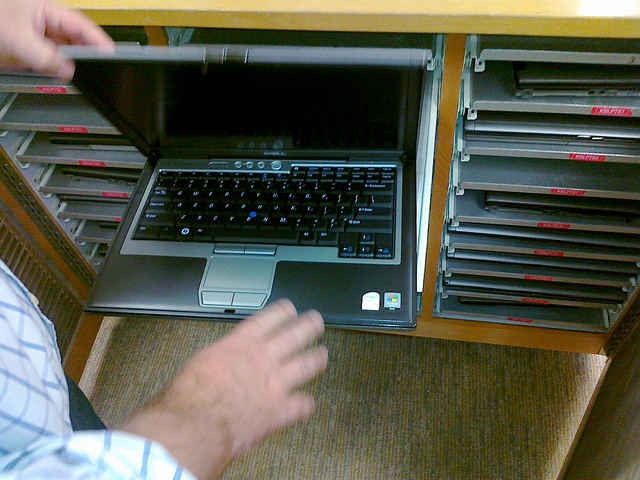Describe the objects in this image and their specific colors. I can see laptop in tan, black, blue, and gray tones, people in tan, pink, darkgray, lavender, and lightblue tones, keyboard in tan, black, teal, blue, and gray tones, laptop in tan, black, gray, purple, and darkgreen tones, and laptop in tan, black, blue, and gray tones in this image. 